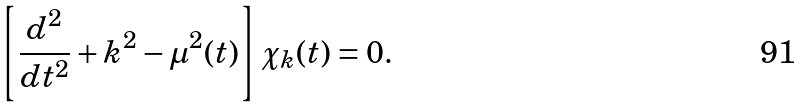<formula> <loc_0><loc_0><loc_500><loc_500>\left [ \frac { d ^ { 2 } } { d t ^ { 2 } } + { k } ^ { 2 } - \mu ^ { 2 } ( t ) \right ] \chi _ { k } ( t ) = 0 .</formula> 